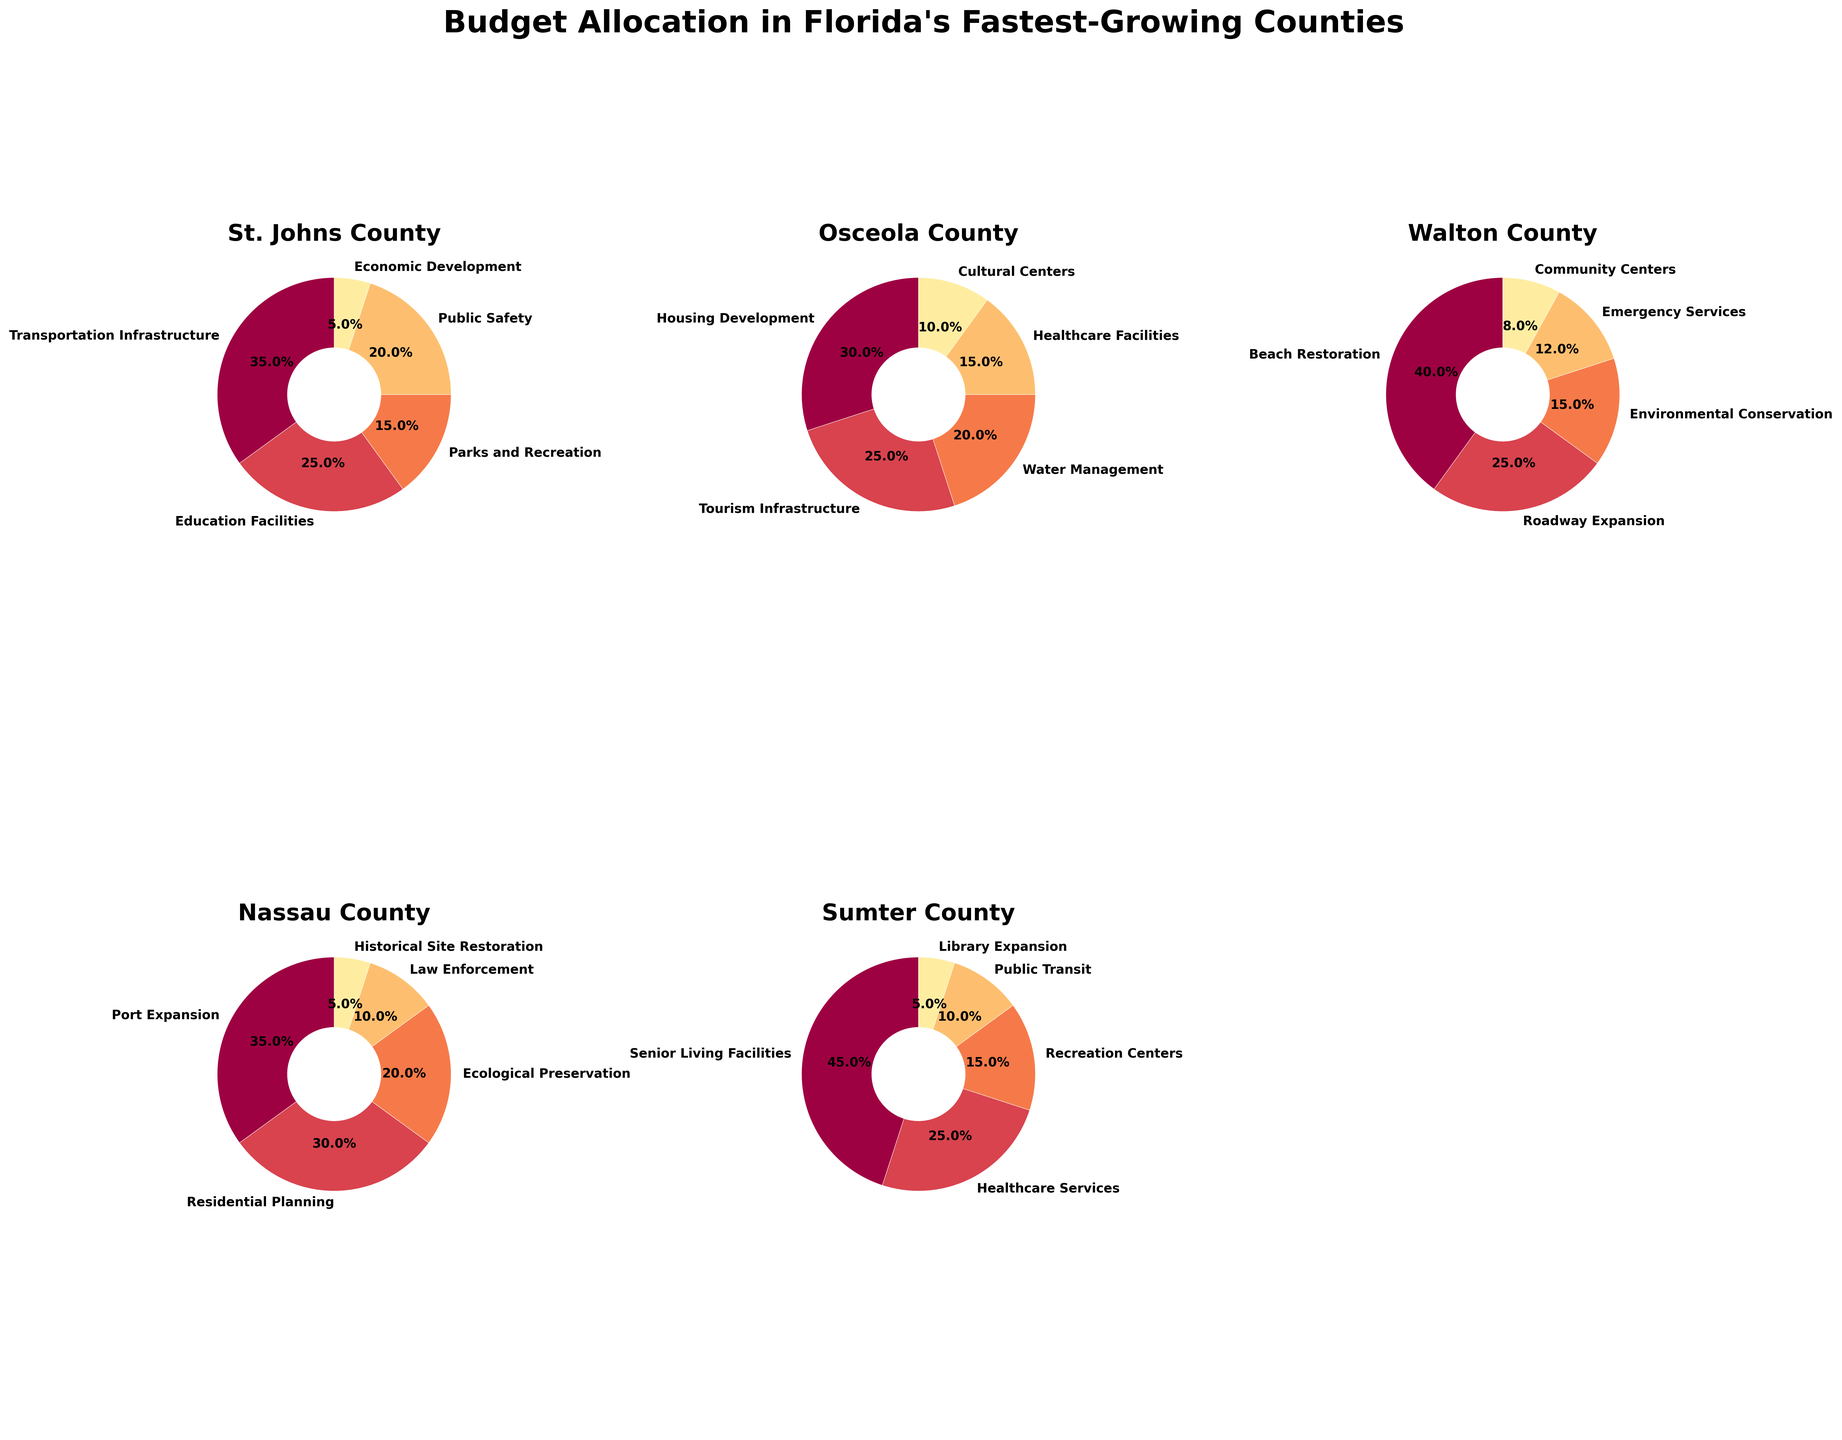What is the total budget allocation percentage for Transportation Infrastructure and Education Facilities in St. Johns County? The pie chart for St. Johns County shows the allocation percentages: Transportation Infrastructure (35%) and Education Facilities (25%). Adding these together: 35% + 25% = 60%.
Answer: 60% Which county allocates the highest percentage to a single project and what is the project? Among all counties, Sumter County allocates the highest percentage to a single project: Senior Living Facilities at 45%.
Answer: Sumter, Senior Living Facilities How does the budget allocation for Public Safety in St. Johns County compare to Law Enforcement in Nassau County? In St. Johns County, Public Safety is allocated 20%, while in Nassau County, Law Enforcement gets 10%. 20% is greater than 10%. Therefore, St. Johns County allocates a higher percentage to Public Safety compared to Nassau County's Law Enforcement.
Answer: St. Johns County allocates more What is the combined percentage of budget allocations dedicated to ecological and environmental projects across all the counties? For each county, the relevant projects and percentages are: 
St. Johns - none specific, 
Osceola - Water Management (20%), 
Walton - Environmental Conservation (15%), 
Nassau - Ecological Preservation (20%), 
Sumter - none specific. Summing these percentages: 20% + 15% + 20% = 55%.
Answer: 55% Which county focuses the least on Public Safety or any similar service, and what is the allocated percentage? The closest comparable services are Public Safety (20%) in St. Johns, Healthcare Facilities (15%) in Osceola, Emergency Services (12%) in Walton, Law Enforcement (10%) in Nassau, and Healthcare Services (25%) in Sumter. The lowest percentage is Law Enforcement in Nassau County at 10%.
Answer: Nassau, 10% Identify the county that allocates budget to Tourism Infrastructure and state the percentage. The chart shows that Osceola County allocates 25% of its budget to Tourism Infrastructure.
Answer: Osceola, 25% What is the difference in budget allocation percentages between Parks and Recreation in St. Johns County and Recreation Centers in Sumter County? Parks and Recreation in St. Johns County is allocated 15%, while Recreation Centers in Sumter County get 15%. The difference is 15% - 15% = 0%.
Answer: 0% If you combined the smallest allocated budget items from Nassau and Walton Counties, what is their total percentage? The smallest allocated budget items are Historical Site Restoration (5%) in Nassau and Community Centers (8%) in Walton. Combining these gives: 5% + 8% = 13%.
Answer: 13% 